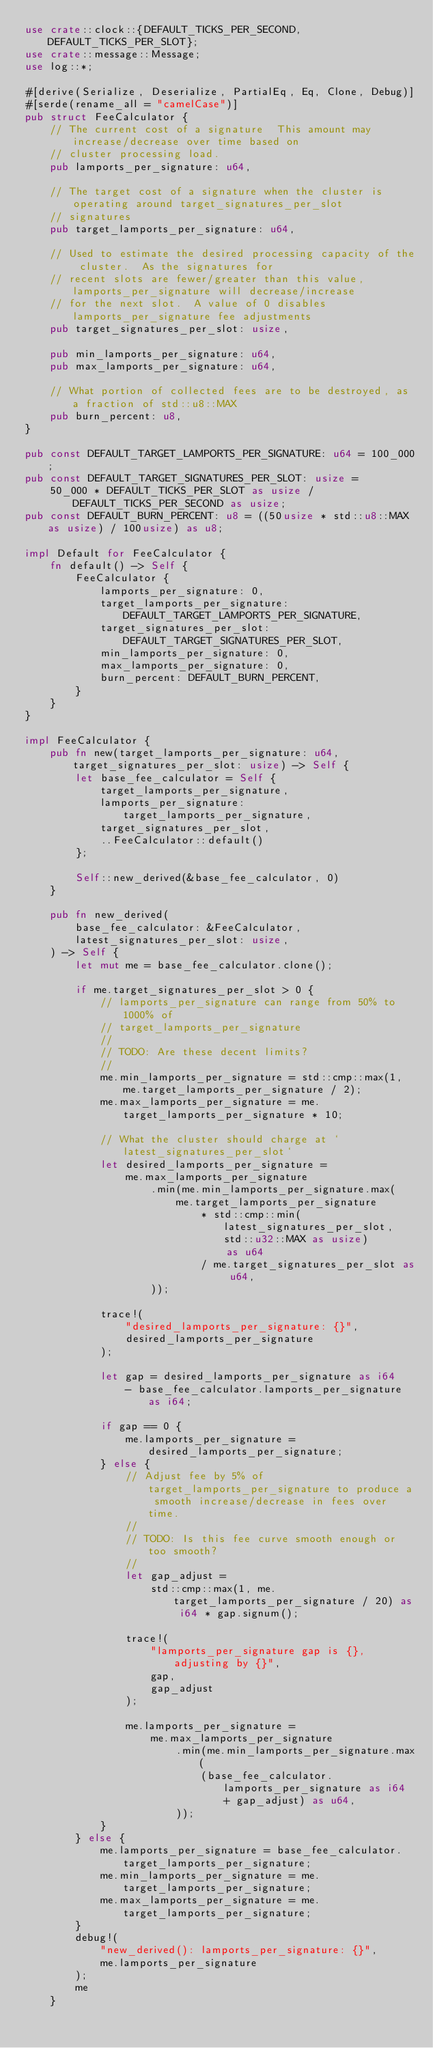Convert code to text. <code><loc_0><loc_0><loc_500><loc_500><_Rust_>use crate::clock::{DEFAULT_TICKS_PER_SECOND, DEFAULT_TICKS_PER_SLOT};
use crate::message::Message;
use log::*;

#[derive(Serialize, Deserialize, PartialEq, Eq, Clone, Debug)]
#[serde(rename_all = "camelCase")]
pub struct FeeCalculator {
    // The current cost of a signature  This amount may increase/decrease over time based on
    // cluster processing load.
    pub lamports_per_signature: u64,

    // The target cost of a signature when the cluster is operating around target_signatures_per_slot
    // signatures
    pub target_lamports_per_signature: u64,

    // Used to estimate the desired processing capacity of the cluster.  As the signatures for
    // recent slots are fewer/greater than this value, lamports_per_signature will decrease/increase
    // for the next slot.  A value of 0 disables lamports_per_signature fee adjustments
    pub target_signatures_per_slot: usize,

    pub min_lamports_per_signature: u64,
    pub max_lamports_per_signature: u64,

    // What portion of collected fees are to be destroyed, as a fraction of std::u8::MAX
    pub burn_percent: u8,
}

pub const DEFAULT_TARGET_LAMPORTS_PER_SIGNATURE: u64 = 100_000;
pub const DEFAULT_TARGET_SIGNATURES_PER_SLOT: usize =
    50_000 * DEFAULT_TICKS_PER_SLOT as usize / DEFAULT_TICKS_PER_SECOND as usize;
pub const DEFAULT_BURN_PERCENT: u8 = ((50usize * std::u8::MAX as usize) / 100usize) as u8;

impl Default for FeeCalculator {
    fn default() -> Self {
        FeeCalculator {
            lamports_per_signature: 0,
            target_lamports_per_signature: DEFAULT_TARGET_LAMPORTS_PER_SIGNATURE,
            target_signatures_per_slot: DEFAULT_TARGET_SIGNATURES_PER_SLOT,
            min_lamports_per_signature: 0,
            max_lamports_per_signature: 0,
            burn_percent: DEFAULT_BURN_PERCENT,
        }
    }
}

impl FeeCalculator {
    pub fn new(target_lamports_per_signature: u64, target_signatures_per_slot: usize) -> Self {
        let base_fee_calculator = Self {
            target_lamports_per_signature,
            lamports_per_signature: target_lamports_per_signature,
            target_signatures_per_slot,
            ..FeeCalculator::default()
        };

        Self::new_derived(&base_fee_calculator, 0)
    }

    pub fn new_derived(
        base_fee_calculator: &FeeCalculator,
        latest_signatures_per_slot: usize,
    ) -> Self {
        let mut me = base_fee_calculator.clone();

        if me.target_signatures_per_slot > 0 {
            // lamports_per_signature can range from 50% to 1000% of
            // target_lamports_per_signature
            //
            // TODO: Are these decent limits?
            //
            me.min_lamports_per_signature = std::cmp::max(1, me.target_lamports_per_signature / 2);
            me.max_lamports_per_signature = me.target_lamports_per_signature * 10;

            // What the cluster should charge at `latest_signatures_per_slot`
            let desired_lamports_per_signature =
                me.max_lamports_per_signature
                    .min(me.min_lamports_per_signature.max(
                        me.target_lamports_per_signature
                            * std::cmp::min(latest_signatures_per_slot, std::u32::MAX as usize)
                                as u64
                            / me.target_signatures_per_slot as u64,
                    ));

            trace!(
                "desired_lamports_per_signature: {}",
                desired_lamports_per_signature
            );

            let gap = desired_lamports_per_signature as i64
                - base_fee_calculator.lamports_per_signature as i64;

            if gap == 0 {
                me.lamports_per_signature = desired_lamports_per_signature;
            } else {
                // Adjust fee by 5% of target_lamports_per_signature to produce a smooth increase/decrease in fees over time.
                //
                // TODO: Is this fee curve smooth enough or too smooth?
                //
                let gap_adjust =
                    std::cmp::max(1, me.target_lamports_per_signature / 20) as i64 * gap.signum();

                trace!(
                    "lamports_per_signature gap is {}, adjusting by {}",
                    gap,
                    gap_adjust
                );

                me.lamports_per_signature =
                    me.max_lamports_per_signature
                        .min(me.min_lamports_per_signature.max(
                            (base_fee_calculator.lamports_per_signature as i64 + gap_adjust) as u64,
                        ));
            }
        } else {
            me.lamports_per_signature = base_fee_calculator.target_lamports_per_signature;
            me.min_lamports_per_signature = me.target_lamports_per_signature;
            me.max_lamports_per_signature = me.target_lamports_per_signature;
        }
        debug!(
            "new_derived(): lamports_per_signature: {}",
            me.lamports_per_signature
        );
        me
    }
</code> 